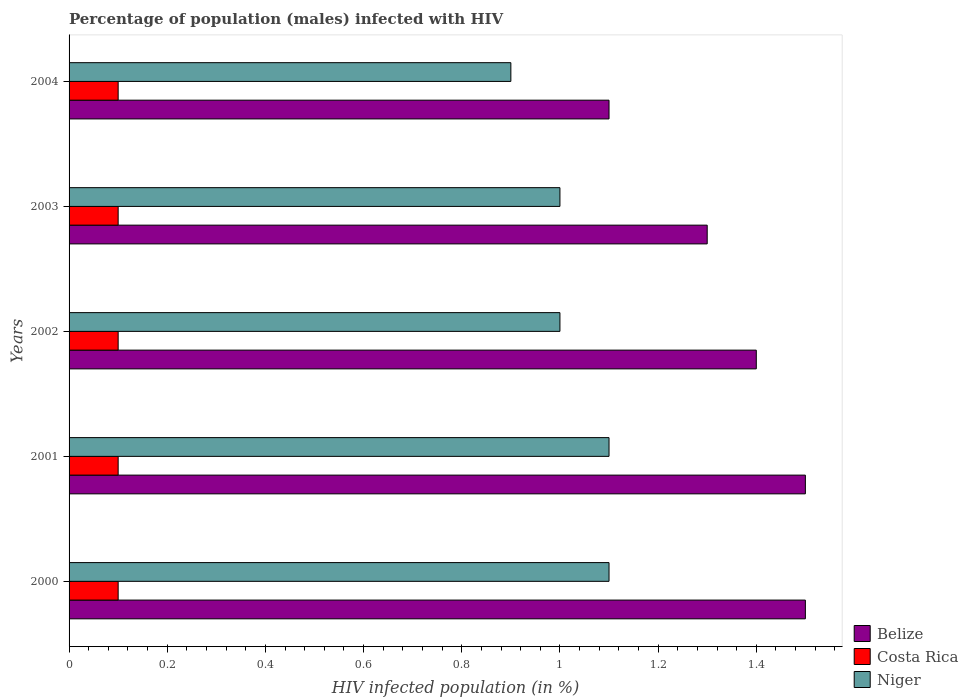How many different coloured bars are there?
Provide a succinct answer. 3. How many groups of bars are there?
Provide a short and direct response. 5. Are the number of bars on each tick of the Y-axis equal?
Make the answer very short. Yes. How many bars are there on the 2nd tick from the bottom?
Make the answer very short. 3. In how many cases, is the number of bars for a given year not equal to the number of legend labels?
Offer a very short reply. 0. In which year was the percentage of HIV infected male population in Niger minimum?
Provide a succinct answer. 2004. What is the total percentage of HIV infected male population in Niger in the graph?
Ensure brevity in your answer.  5.1. What is the difference between the percentage of HIV infected male population in Costa Rica in 2001 and that in 2003?
Provide a succinct answer. 0. What is the average percentage of HIV infected male population in Costa Rica per year?
Provide a succinct answer. 0.1. In the year 2000, what is the difference between the percentage of HIV infected male population in Niger and percentage of HIV infected male population in Costa Rica?
Make the answer very short. 1. In how many years, is the percentage of HIV infected male population in Costa Rica greater than 0.44 %?
Your response must be concise. 0. What is the ratio of the percentage of HIV infected male population in Niger in 2001 to that in 2003?
Ensure brevity in your answer.  1.1. Is the difference between the percentage of HIV infected male population in Niger in 2002 and 2003 greater than the difference between the percentage of HIV infected male population in Costa Rica in 2002 and 2003?
Your answer should be very brief. No. What is the difference between the highest and the second highest percentage of HIV infected male population in Belize?
Your response must be concise. 0. What is the difference between the highest and the lowest percentage of HIV infected male population in Niger?
Your answer should be compact. 0.2. Is the sum of the percentage of HIV infected male population in Niger in 2000 and 2001 greater than the maximum percentage of HIV infected male population in Belize across all years?
Your response must be concise. Yes. What does the 2nd bar from the top in 2004 represents?
Keep it short and to the point. Costa Rica. What does the 2nd bar from the bottom in 2001 represents?
Keep it short and to the point. Costa Rica. What is the difference between two consecutive major ticks on the X-axis?
Provide a succinct answer. 0.2. Are the values on the major ticks of X-axis written in scientific E-notation?
Give a very brief answer. No. Does the graph contain any zero values?
Keep it short and to the point. No. Where does the legend appear in the graph?
Make the answer very short. Bottom right. How are the legend labels stacked?
Keep it short and to the point. Vertical. What is the title of the graph?
Offer a terse response. Percentage of population (males) infected with HIV. What is the label or title of the X-axis?
Give a very brief answer. HIV infected population (in %). What is the label or title of the Y-axis?
Give a very brief answer. Years. What is the HIV infected population (in %) of Belize in 2001?
Your response must be concise. 1.5. What is the HIV infected population (in %) in Niger in 2001?
Provide a succinct answer. 1.1. What is the HIV infected population (in %) in Belize in 2002?
Make the answer very short. 1.4. What is the HIV infected population (in %) of Costa Rica in 2002?
Ensure brevity in your answer.  0.1. What is the HIV infected population (in %) of Niger in 2002?
Offer a very short reply. 1. What is the HIV infected population (in %) of Costa Rica in 2004?
Make the answer very short. 0.1. What is the HIV infected population (in %) in Niger in 2004?
Make the answer very short. 0.9. Across all years, what is the minimum HIV infected population (in %) of Costa Rica?
Provide a short and direct response. 0.1. Across all years, what is the minimum HIV infected population (in %) in Niger?
Make the answer very short. 0.9. What is the total HIV infected population (in %) of Belize in the graph?
Your answer should be compact. 6.8. What is the total HIV infected population (in %) of Niger in the graph?
Offer a very short reply. 5.1. What is the difference between the HIV infected population (in %) of Belize in 2000 and that in 2001?
Provide a short and direct response. 0. What is the difference between the HIV infected population (in %) of Costa Rica in 2000 and that in 2001?
Offer a very short reply. 0. What is the difference between the HIV infected population (in %) of Niger in 2000 and that in 2001?
Your answer should be very brief. 0. What is the difference between the HIV infected population (in %) of Costa Rica in 2000 and that in 2002?
Give a very brief answer. 0. What is the difference between the HIV infected population (in %) of Niger in 2000 and that in 2002?
Ensure brevity in your answer.  0.1. What is the difference between the HIV infected population (in %) in Belize in 2000 and that in 2004?
Provide a succinct answer. 0.4. What is the difference between the HIV infected population (in %) of Belize in 2001 and that in 2002?
Your answer should be compact. 0.1. What is the difference between the HIV infected population (in %) of Costa Rica in 2001 and that in 2002?
Give a very brief answer. 0. What is the difference between the HIV infected population (in %) in Niger in 2001 and that in 2002?
Offer a very short reply. 0.1. What is the difference between the HIV infected population (in %) in Belize in 2001 and that in 2003?
Ensure brevity in your answer.  0.2. What is the difference between the HIV infected population (in %) of Costa Rica in 2001 and that in 2003?
Ensure brevity in your answer.  0. What is the difference between the HIV infected population (in %) in Niger in 2001 and that in 2003?
Your response must be concise. 0.1. What is the difference between the HIV infected population (in %) of Costa Rica in 2002 and that in 2003?
Provide a succinct answer. 0. What is the difference between the HIV infected population (in %) of Belize in 2002 and that in 2004?
Your answer should be very brief. 0.3. What is the difference between the HIV infected population (in %) of Niger in 2002 and that in 2004?
Give a very brief answer. 0.1. What is the difference between the HIV infected population (in %) of Belize in 2003 and that in 2004?
Make the answer very short. 0.2. What is the difference between the HIV infected population (in %) in Costa Rica in 2003 and that in 2004?
Ensure brevity in your answer.  0. What is the difference between the HIV infected population (in %) in Costa Rica in 2000 and the HIV infected population (in %) in Niger in 2001?
Keep it short and to the point. -1. What is the difference between the HIV infected population (in %) in Belize in 2000 and the HIV infected population (in %) in Niger in 2002?
Ensure brevity in your answer.  0.5. What is the difference between the HIV infected population (in %) in Belize in 2000 and the HIV infected population (in %) in Niger in 2003?
Make the answer very short. 0.5. What is the difference between the HIV infected population (in %) in Costa Rica in 2000 and the HIV infected population (in %) in Niger in 2003?
Give a very brief answer. -0.9. What is the difference between the HIV infected population (in %) in Costa Rica in 2000 and the HIV infected population (in %) in Niger in 2004?
Give a very brief answer. -0.8. What is the difference between the HIV infected population (in %) of Belize in 2001 and the HIV infected population (in %) of Costa Rica in 2002?
Provide a succinct answer. 1.4. What is the difference between the HIV infected population (in %) in Costa Rica in 2001 and the HIV infected population (in %) in Niger in 2002?
Keep it short and to the point. -0.9. What is the difference between the HIV infected population (in %) of Belize in 2001 and the HIV infected population (in %) of Niger in 2003?
Keep it short and to the point. 0.5. What is the difference between the HIV infected population (in %) in Belize in 2001 and the HIV infected population (in %) in Niger in 2004?
Offer a terse response. 0.6. What is the difference between the HIV infected population (in %) of Costa Rica in 2001 and the HIV infected population (in %) of Niger in 2004?
Offer a terse response. -0.8. What is the difference between the HIV infected population (in %) of Belize in 2002 and the HIV infected population (in %) of Costa Rica in 2004?
Your response must be concise. 1.3. What is the difference between the HIV infected population (in %) of Belize in 2002 and the HIV infected population (in %) of Niger in 2004?
Provide a short and direct response. 0.5. What is the difference between the HIV infected population (in %) of Costa Rica in 2002 and the HIV infected population (in %) of Niger in 2004?
Offer a very short reply. -0.8. What is the difference between the HIV infected population (in %) of Belize in 2003 and the HIV infected population (in %) of Costa Rica in 2004?
Make the answer very short. 1.2. What is the difference between the HIV infected population (in %) of Costa Rica in 2003 and the HIV infected population (in %) of Niger in 2004?
Make the answer very short. -0.8. What is the average HIV infected population (in %) in Belize per year?
Keep it short and to the point. 1.36. What is the average HIV infected population (in %) in Costa Rica per year?
Your answer should be compact. 0.1. What is the average HIV infected population (in %) of Niger per year?
Ensure brevity in your answer.  1.02. In the year 2000, what is the difference between the HIV infected population (in %) of Belize and HIV infected population (in %) of Costa Rica?
Give a very brief answer. 1.4. In the year 2001, what is the difference between the HIV infected population (in %) in Belize and HIV infected population (in %) in Costa Rica?
Offer a very short reply. 1.4. In the year 2001, what is the difference between the HIV infected population (in %) in Costa Rica and HIV infected population (in %) in Niger?
Provide a succinct answer. -1. In the year 2002, what is the difference between the HIV infected population (in %) in Belize and HIV infected population (in %) in Costa Rica?
Make the answer very short. 1.3. In the year 2002, what is the difference between the HIV infected population (in %) in Belize and HIV infected population (in %) in Niger?
Provide a succinct answer. 0.4. In the year 2002, what is the difference between the HIV infected population (in %) of Costa Rica and HIV infected population (in %) of Niger?
Your answer should be compact. -0.9. In the year 2003, what is the difference between the HIV infected population (in %) in Belize and HIV infected population (in %) in Niger?
Keep it short and to the point. 0.3. In the year 2004, what is the difference between the HIV infected population (in %) of Belize and HIV infected population (in %) of Costa Rica?
Offer a terse response. 1. What is the ratio of the HIV infected population (in %) in Belize in 2000 to that in 2001?
Give a very brief answer. 1. What is the ratio of the HIV infected population (in %) of Costa Rica in 2000 to that in 2001?
Keep it short and to the point. 1. What is the ratio of the HIV infected population (in %) in Belize in 2000 to that in 2002?
Provide a succinct answer. 1.07. What is the ratio of the HIV infected population (in %) of Costa Rica in 2000 to that in 2002?
Ensure brevity in your answer.  1. What is the ratio of the HIV infected population (in %) of Belize in 2000 to that in 2003?
Provide a succinct answer. 1.15. What is the ratio of the HIV infected population (in %) of Costa Rica in 2000 to that in 2003?
Provide a short and direct response. 1. What is the ratio of the HIV infected population (in %) in Belize in 2000 to that in 2004?
Your response must be concise. 1.36. What is the ratio of the HIV infected population (in %) in Costa Rica in 2000 to that in 2004?
Make the answer very short. 1. What is the ratio of the HIV infected population (in %) in Niger in 2000 to that in 2004?
Keep it short and to the point. 1.22. What is the ratio of the HIV infected population (in %) of Belize in 2001 to that in 2002?
Your response must be concise. 1.07. What is the ratio of the HIV infected population (in %) in Niger in 2001 to that in 2002?
Your answer should be very brief. 1.1. What is the ratio of the HIV infected population (in %) in Belize in 2001 to that in 2003?
Keep it short and to the point. 1.15. What is the ratio of the HIV infected population (in %) in Niger in 2001 to that in 2003?
Ensure brevity in your answer.  1.1. What is the ratio of the HIV infected population (in %) of Belize in 2001 to that in 2004?
Your answer should be very brief. 1.36. What is the ratio of the HIV infected population (in %) in Niger in 2001 to that in 2004?
Ensure brevity in your answer.  1.22. What is the ratio of the HIV infected population (in %) of Belize in 2002 to that in 2004?
Your answer should be compact. 1.27. What is the ratio of the HIV infected population (in %) in Niger in 2002 to that in 2004?
Make the answer very short. 1.11. What is the ratio of the HIV infected population (in %) of Belize in 2003 to that in 2004?
Your answer should be compact. 1.18. What is the ratio of the HIV infected population (in %) of Costa Rica in 2003 to that in 2004?
Make the answer very short. 1. What is the difference between the highest and the second highest HIV infected population (in %) in Costa Rica?
Make the answer very short. 0. What is the difference between the highest and the lowest HIV infected population (in %) of Belize?
Your response must be concise. 0.4. 